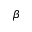<formula> <loc_0><loc_0><loc_500><loc_500>\beta</formula> 